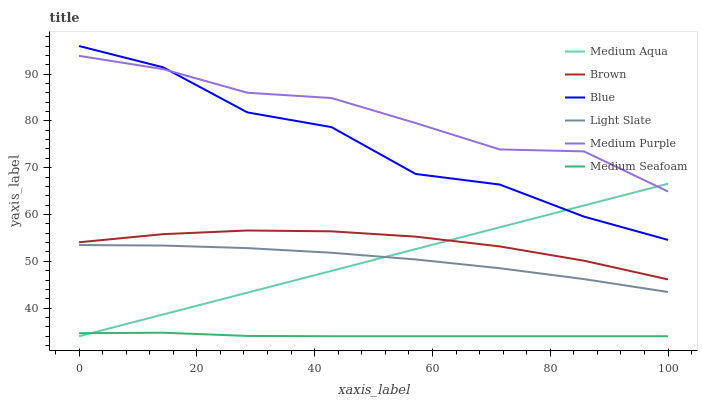Does Medium Seafoam have the minimum area under the curve?
Answer yes or no. Yes. Does Medium Purple have the maximum area under the curve?
Answer yes or no. Yes. Does Brown have the minimum area under the curve?
Answer yes or no. No. Does Brown have the maximum area under the curve?
Answer yes or no. No. Is Medium Aqua the smoothest?
Answer yes or no. Yes. Is Blue the roughest?
Answer yes or no. Yes. Is Brown the smoothest?
Answer yes or no. No. Is Brown the roughest?
Answer yes or no. No. Does Brown have the lowest value?
Answer yes or no. No. Does Blue have the highest value?
Answer yes or no. Yes. Does Brown have the highest value?
Answer yes or no. No. Is Brown less than Blue?
Answer yes or no. Yes. Is Brown greater than Medium Seafoam?
Answer yes or no. Yes. Does Blue intersect Medium Purple?
Answer yes or no. Yes. Is Blue less than Medium Purple?
Answer yes or no. No. Is Blue greater than Medium Purple?
Answer yes or no. No. Does Brown intersect Blue?
Answer yes or no. No. 